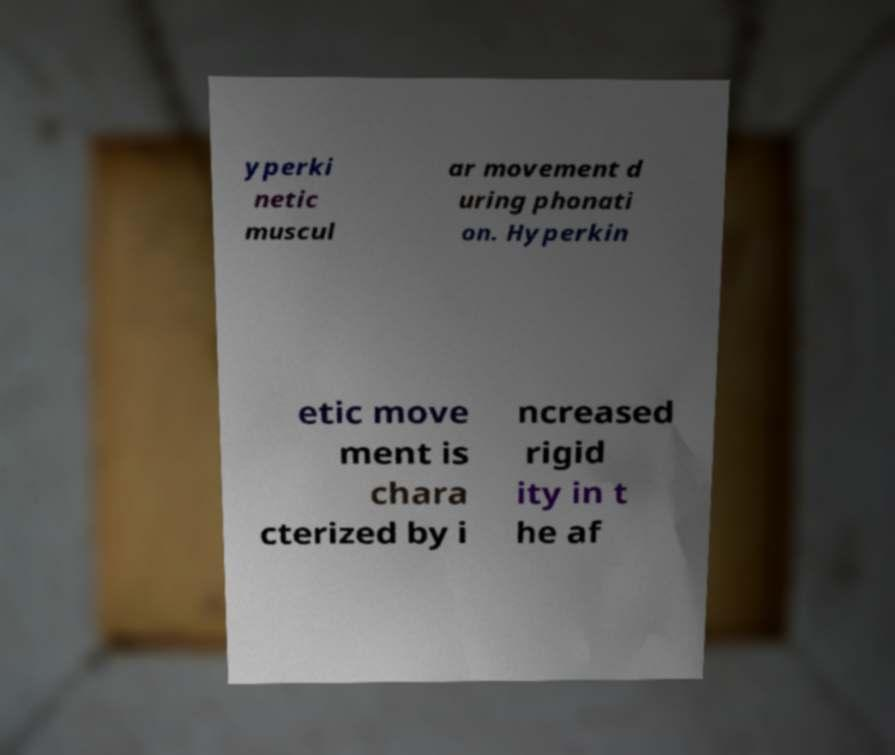Can you accurately transcribe the text from the provided image for me? yperki netic muscul ar movement d uring phonati on. Hyperkin etic move ment is chara cterized by i ncreased rigid ity in t he af 